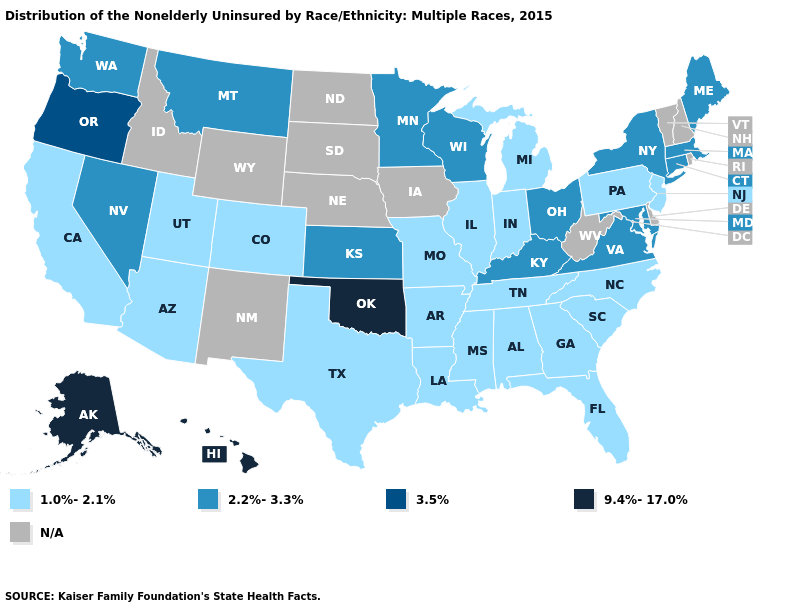Name the states that have a value in the range N/A?
Keep it brief. Delaware, Idaho, Iowa, Nebraska, New Hampshire, New Mexico, North Dakota, Rhode Island, South Dakota, Vermont, West Virginia, Wyoming. Name the states that have a value in the range 9.4%-17.0%?
Quick response, please. Alaska, Hawaii, Oklahoma. What is the value of West Virginia?
Short answer required. N/A. Among the states that border Oregon , which have the highest value?
Answer briefly. Nevada, Washington. What is the highest value in the MidWest ?
Short answer required. 2.2%-3.3%. Among the states that border Arkansas , does Louisiana have the lowest value?
Write a very short answer. Yes. Name the states that have a value in the range 9.4%-17.0%?
Keep it brief. Alaska, Hawaii, Oklahoma. What is the value of Kansas?
Be succinct. 2.2%-3.3%. Among the states that border Nevada , which have the lowest value?
Quick response, please. Arizona, California, Utah. Which states hav the highest value in the Northeast?
Concise answer only. Connecticut, Maine, Massachusetts, New York. Name the states that have a value in the range 2.2%-3.3%?
Quick response, please. Connecticut, Kansas, Kentucky, Maine, Maryland, Massachusetts, Minnesota, Montana, Nevada, New York, Ohio, Virginia, Washington, Wisconsin. Among the states that border Iowa , which have the highest value?
Write a very short answer. Minnesota, Wisconsin. Among the states that border Virginia , which have the lowest value?
Concise answer only. North Carolina, Tennessee. Is the legend a continuous bar?
Concise answer only. No. What is the value of North Dakota?
Concise answer only. N/A. 